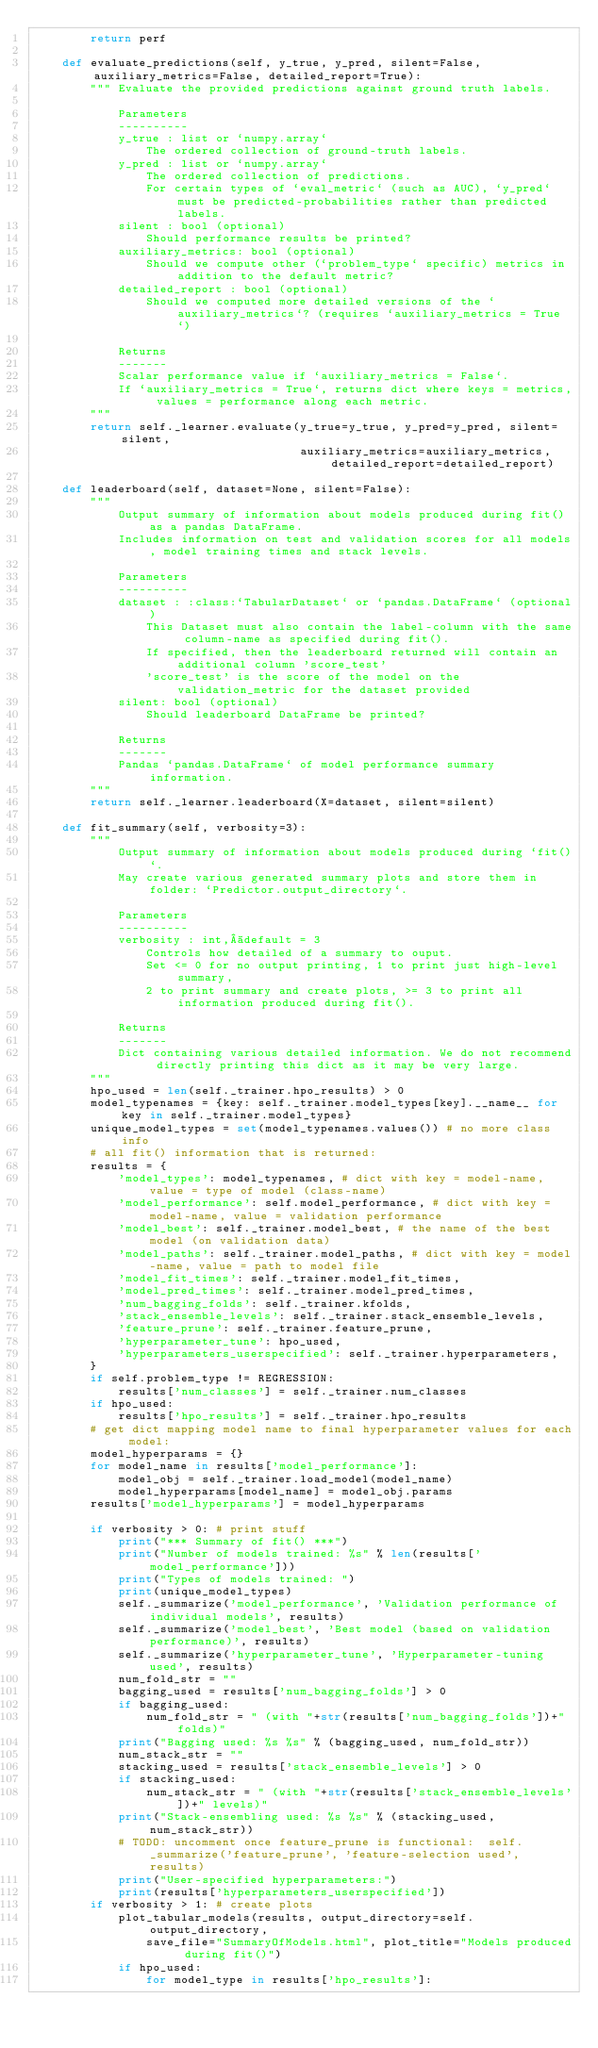Convert code to text. <code><loc_0><loc_0><loc_500><loc_500><_Python_>        return perf

    def evaluate_predictions(self, y_true, y_pred, silent=False, auxiliary_metrics=False, detailed_report=True):
        """ Evaluate the provided predictions against ground truth labels. 

            Parameters
            ----------
            y_true : list or `numpy.array`
                The ordered collection of ground-truth labels. 
            y_pred : list or `numpy.array`
                The ordered collection of predictions. 
                For certain types of `eval_metric` (such as AUC), `y_pred` must be predicted-probabilities rather than predicted labels.
            silent : bool (optional)
                Should performance results be printed?
            auxiliary_metrics: bool (optional)
                Should we compute other (`problem_type` specific) metrics in addition to the default metric?
            detailed_report : bool (optional) 
                Should we computed more detailed versions of the `auxiliary_metrics`? (requires `auxiliary_metrics = True`)

            Returns
            -------
            Scalar performance value if `auxiliary_metrics = False`. 
            If `auxiliary_metrics = True`, returns dict where keys = metrics, values = performance along each metric.
        """
        return self._learner.evaluate(y_true=y_true, y_pred=y_pred, silent=silent, 
                                      auxiliary_metrics=auxiliary_metrics, detailed_report=detailed_report)

    def leaderboard(self, dataset=None, silent=False):
        """
            Output summary of information about models produced during fit() as a pandas DataFrame.
            Includes information on test and validation scores for all models, model training times and stack levels.

            Parameters
            ----------
            dataset : :class:`TabularDataset` or `pandas.DataFrame` (optional)
                This Dataset must also contain the label-column with the same column-name as specified during fit().
                If specified, then the leaderboard returned will contain an additional column 'score_test'
                'score_test' is the score of the model on the validation_metric for the dataset provided
            silent: bool (optional)
                Should leaderboard DataFrame be printed?

            Returns
            -------
            Pandas `pandas.DataFrame` of model performance summary information.
        """
        return self._learner.leaderboard(X=dataset, silent=silent)

    def fit_summary(self, verbosity=3):
        """
            Output summary of information about models produced during `fit()`.
            May create various generated summary plots and store them in folder: `Predictor.output_directory`.

            Parameters
            ----------
            verbosity : int, default = 3
                Controls how detailed of a summary to ouput. 
                Set <= 0 for no output printing, 1 to print just high-level summary, 
                2 to print summary and create plots, >= 3 to print all information produced during fit().

            Returns
            -------
            Dict containing various detailed information. We do not recommend directly printing this dict as it may be very large.
        """
        hpo_used = len(self._trainer.hpo_results) > 0
        model_typenames = {key: self._trainer.model_types[key].__name__ for key in self._trainer.model_types}
        unique_model_types = set(model_typenames.values()) # no more class info
        # all fit() information that is returned:
        results = {
            'model_types': model_typenames, # dict with key = model-name, value = type of model (class-name)
            'model_performance': self.model_performance, # dict with key = model-name, value = validation performance
            'model_best': self._trainer.model_best, # the name of the best model (on validation data)
            'model_paths': self._trainer.model_paths, # dict with key = model-name, value = path to model file
            'model_fit_times': self._trainer.model_fit_times,
            'model_pred_times': self._trainer.model_pred_times,
            'num_bagging_folds': self._trainer.kfolds,
            'stack_ensemble_levels': self._trainer.stack_ensemble_levels,
            'feature_prune': self._trainer.feature_prune,
            'hyperparameter_tune': hpo_used,
            'hyperparameters_userspecified': self._trainer.hyperparameters,
        }
        if self.problem_type != REGRESSION:
            results['num_classes'] = self._trainer.num_classes
        if hpo_used:
            results['hpo_results'] = self._trainer.hpo_results
        # get dict mapping model name to final hyperparameter values for each model:
        model_hyperparams = {}
        for model_name in results['model_performance']:
            model_obj = self._trainer.load_model(model_name)
            model_hyperparams[model_name] = model_obj.params
        results['model_hyperparams'] = model_hyperparams

        if verbosity > 0: # print stuff
            print("*** Summary of fit() ***")
            print("Number of models trained: %s" % len(results['model_performance']))
            print("Types of models trained: ")
            print(unique_model_types)
            self._summarize('model_performance', 'Validation performance of individual models', results)
            self._summarize('model_best', 'Best model (based on validation performance)', results)
            self._summarize('hyperparameter_tune', 'Hyperparameter-tuning used', results)
            num_fold_str = ""
            bagging_used = results['num_bagging_folds'] > 0
            if bagging_used:
                num_fold_str = " (with "+str(results['num_bagging_folds'])+" folds)"
            print("Bagging used: %s %s" % (bagging_used, num_fold_str))
            num_stack_str = ""
            stacking_used = results['stack_ensemble_levels'] > 0
            if stacking_used:
                num_stack_str = " (with "+str(results['stack_ensemble_levels'])+" levels)"
            print("Stack-ensembling used: %s %s" % (stacking_used, num_stack_str))
            # TODO: uncomment once feature_prune is functional:  self._summarize('feature_prune', 'feature-selection used', results)
            print("User-specified hyperparameters:")
            print(results['hyperparameters_userspecified'])
        if verbosity > 1: # create plots
            plot_tabular_models(results, output_directory=self.output_directory, 
                save_file="SummaryOfModels.html", plot_title="Models produced during fit()")
            if hpo_used:
                for model_type in results['hpo_results']:</code> 